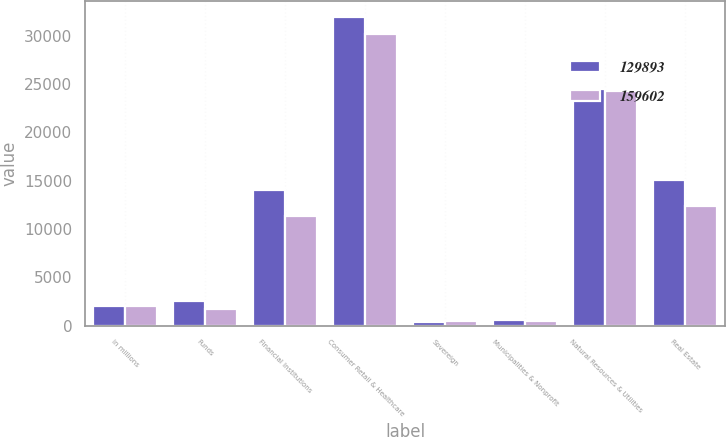Convert chart. <chart><loc_0><loc_0><loc_500><loc_500><stacked_bar_chart><ecel><fcel>in millions<fcel>Funds<fcel>Financial Institutions<fcel>Consumer Retail & Healthcare<fcel>Sovereign<fcel>Municipalities & Nonprofit<fcel>Natural Resources & Utilities<fcel>Real Estate<nl><fcel>129893<fcel>2015<fcel>2595<fcel>14063<fcel>31944<fcel>419<fcel>628<fcel>24476<fcel>15045<nl><fcel>159602<fcel>2014<fcel>1706<fcel>11316<fcel>30216<fcel>450<fcel>541<fcel>24275<fcel>12366<nl></chart> 